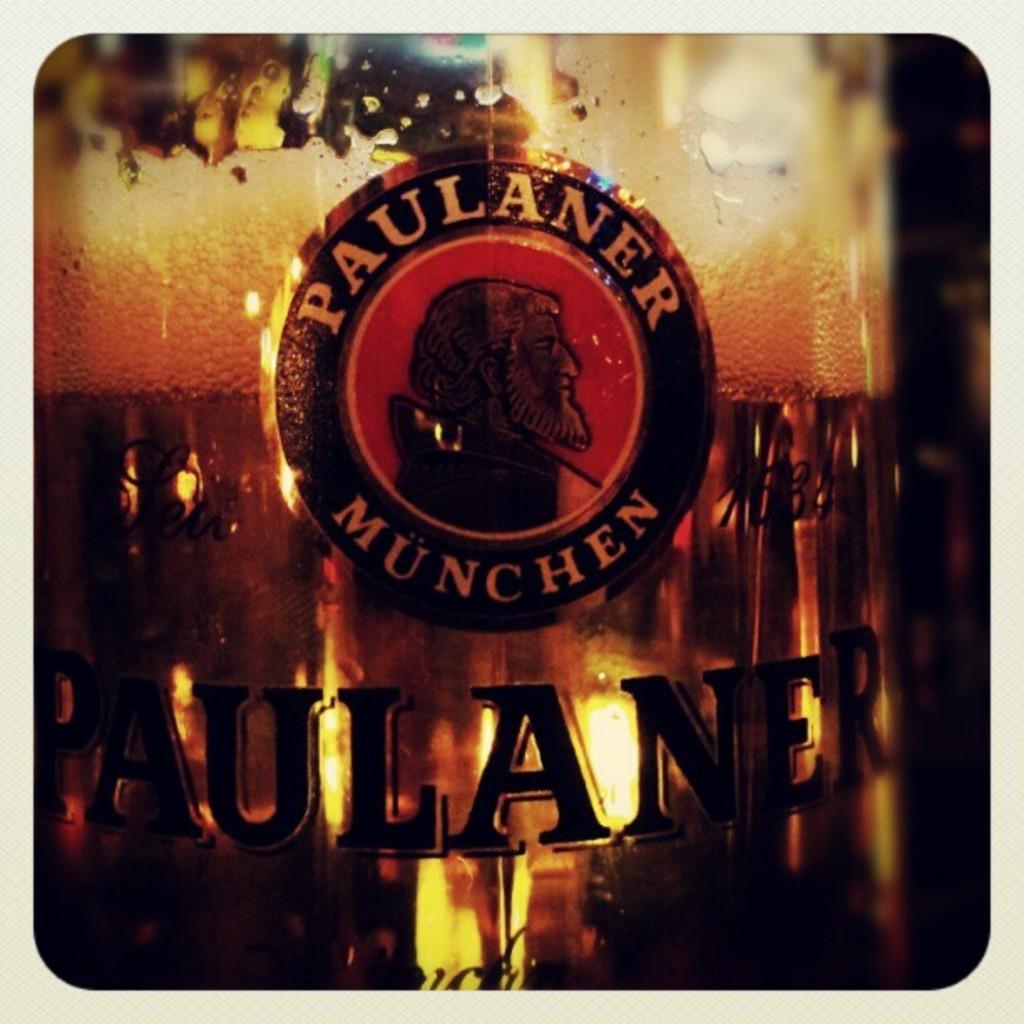What is the name brand?
Your answer should be compact. Paulaner munchen. Which year was this beer brewed?
Ensure brevity in your answer.  Unanswerable. 